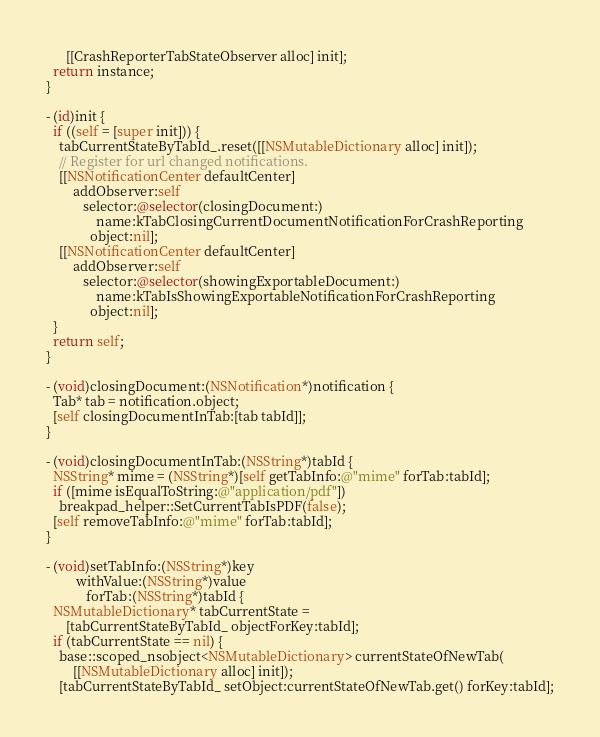Convert code to text. <code><loc_0><loc_0><loc_500><loc_500><_ObjectiveC_>      [[CrashReporterTabStateObserver alloc] init];
  return instance;
}

- (id)init {
  if ((self = [super init])) {
    tabCurrentStateByTabId_.reset([[NSMutableDictionary alloc] init]);
    // Register for url changed notifications.
    [[NSNotificationCenter defaultCenter]
        addObserver:self
           selector:@selector(closingDocument:)
               name:kTabClosingCurrentDocumentNotificationForCrashReporting
             object:nil];
    [[NSNotificationCenter defaultCenter]
        addObserver:self
           selector:@selector(showingExportableDocument:)
               name:kTabIsShowingExportableNotificationForCrashReporting
             object:nil];
  }
  return self;
}

- (void)closingDocument:(NSNotification*)notification {
  Tab* tab = notification.object;
  [self closingDocumentInTab:[tab tabId]];
}

- (void)closingDocumentInTab:(NSString*)tabId {
  NSString* mime = (NSString*)[self getTabInfo:@"mime" forTab:tabId];
  if ([mime isEqualToString:@"application/pdf"])
    breakpad_helper::SetCurrentTabIsPDF(false);
  [self removeTabInfo:@"mime" forTab:tabId];
}

- (void)setTabInfo:(NSString*)key
         withValue:(NSString*)value
            forTab:(NSString*)tabId {
  NSMutableDictionary* tabCurrentState =
      [tabCurrentStateByTabId_ objectForKey:tabId];
  if (tabCurrentState == nil) {
    base::scoped_nsobject<NSMutableDictionary> currentStateOfNewTab(
        [[NSMutableDictionary alloc] init]);
    [tabCurrentStateByTabId_ setObject:currentStateOfNewTab.get() forKey:tabId];</code> 